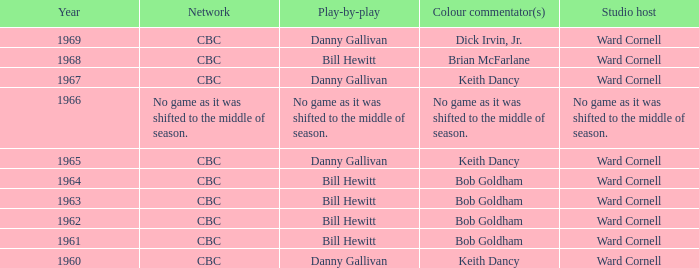Who took part in the play-by-play while working with studio host ward cornell and color commentator bob goldham? Bill Hewitt, Bill Hewitt, Bill Hewitt, Bill Hewitt. 